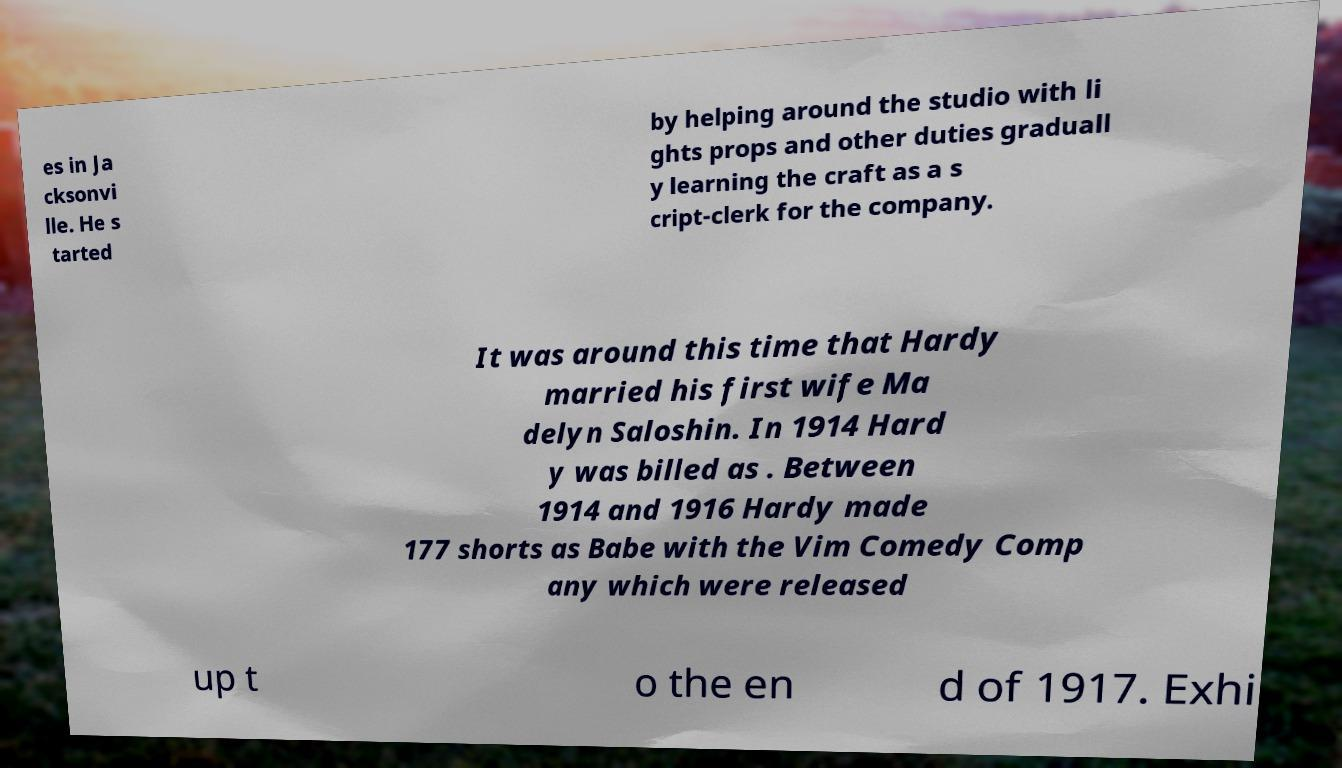I need the written content from this picture converted into text. Can you do that? es in Ja cksonvi lle. He s tarted by helping around the studio with li ghts props and other duties graduall y learning the craft as a s cript-clerk for the company. It was around this time that Hardy married his first wife Ma delyn Saloshin. In 1914 Hard y was billed as . Between 1914 and 1916 Hardy made 177 shorts as Babe with the Vim Comedy Comp any which were released up t o the en d of 1917. Exhi 